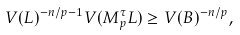Convert formula to latex. <formula><loc_0><loc_0><loc_500><loc_500>V ( L ) ^ { - n / p - 1 } V ( M _ { p } ^ { \tau } L ) \geq V ( B ) ^ { - n / p } ,</formula> 